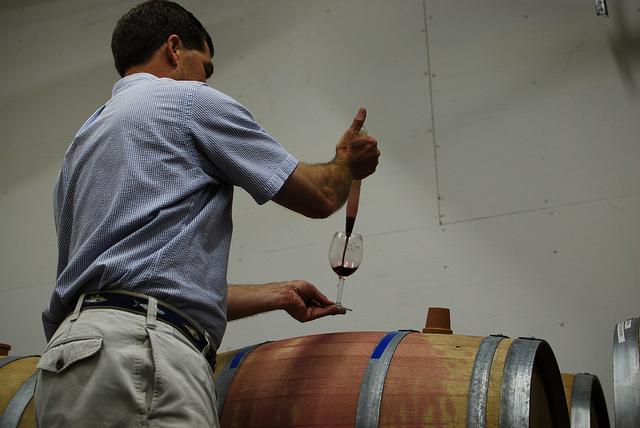How much wine is in the glass?
Answer briefly. Little. What is the wine stored in?
Concise answer only. Barrel. Why is the cask pink?
Answer briefly. Stained. 